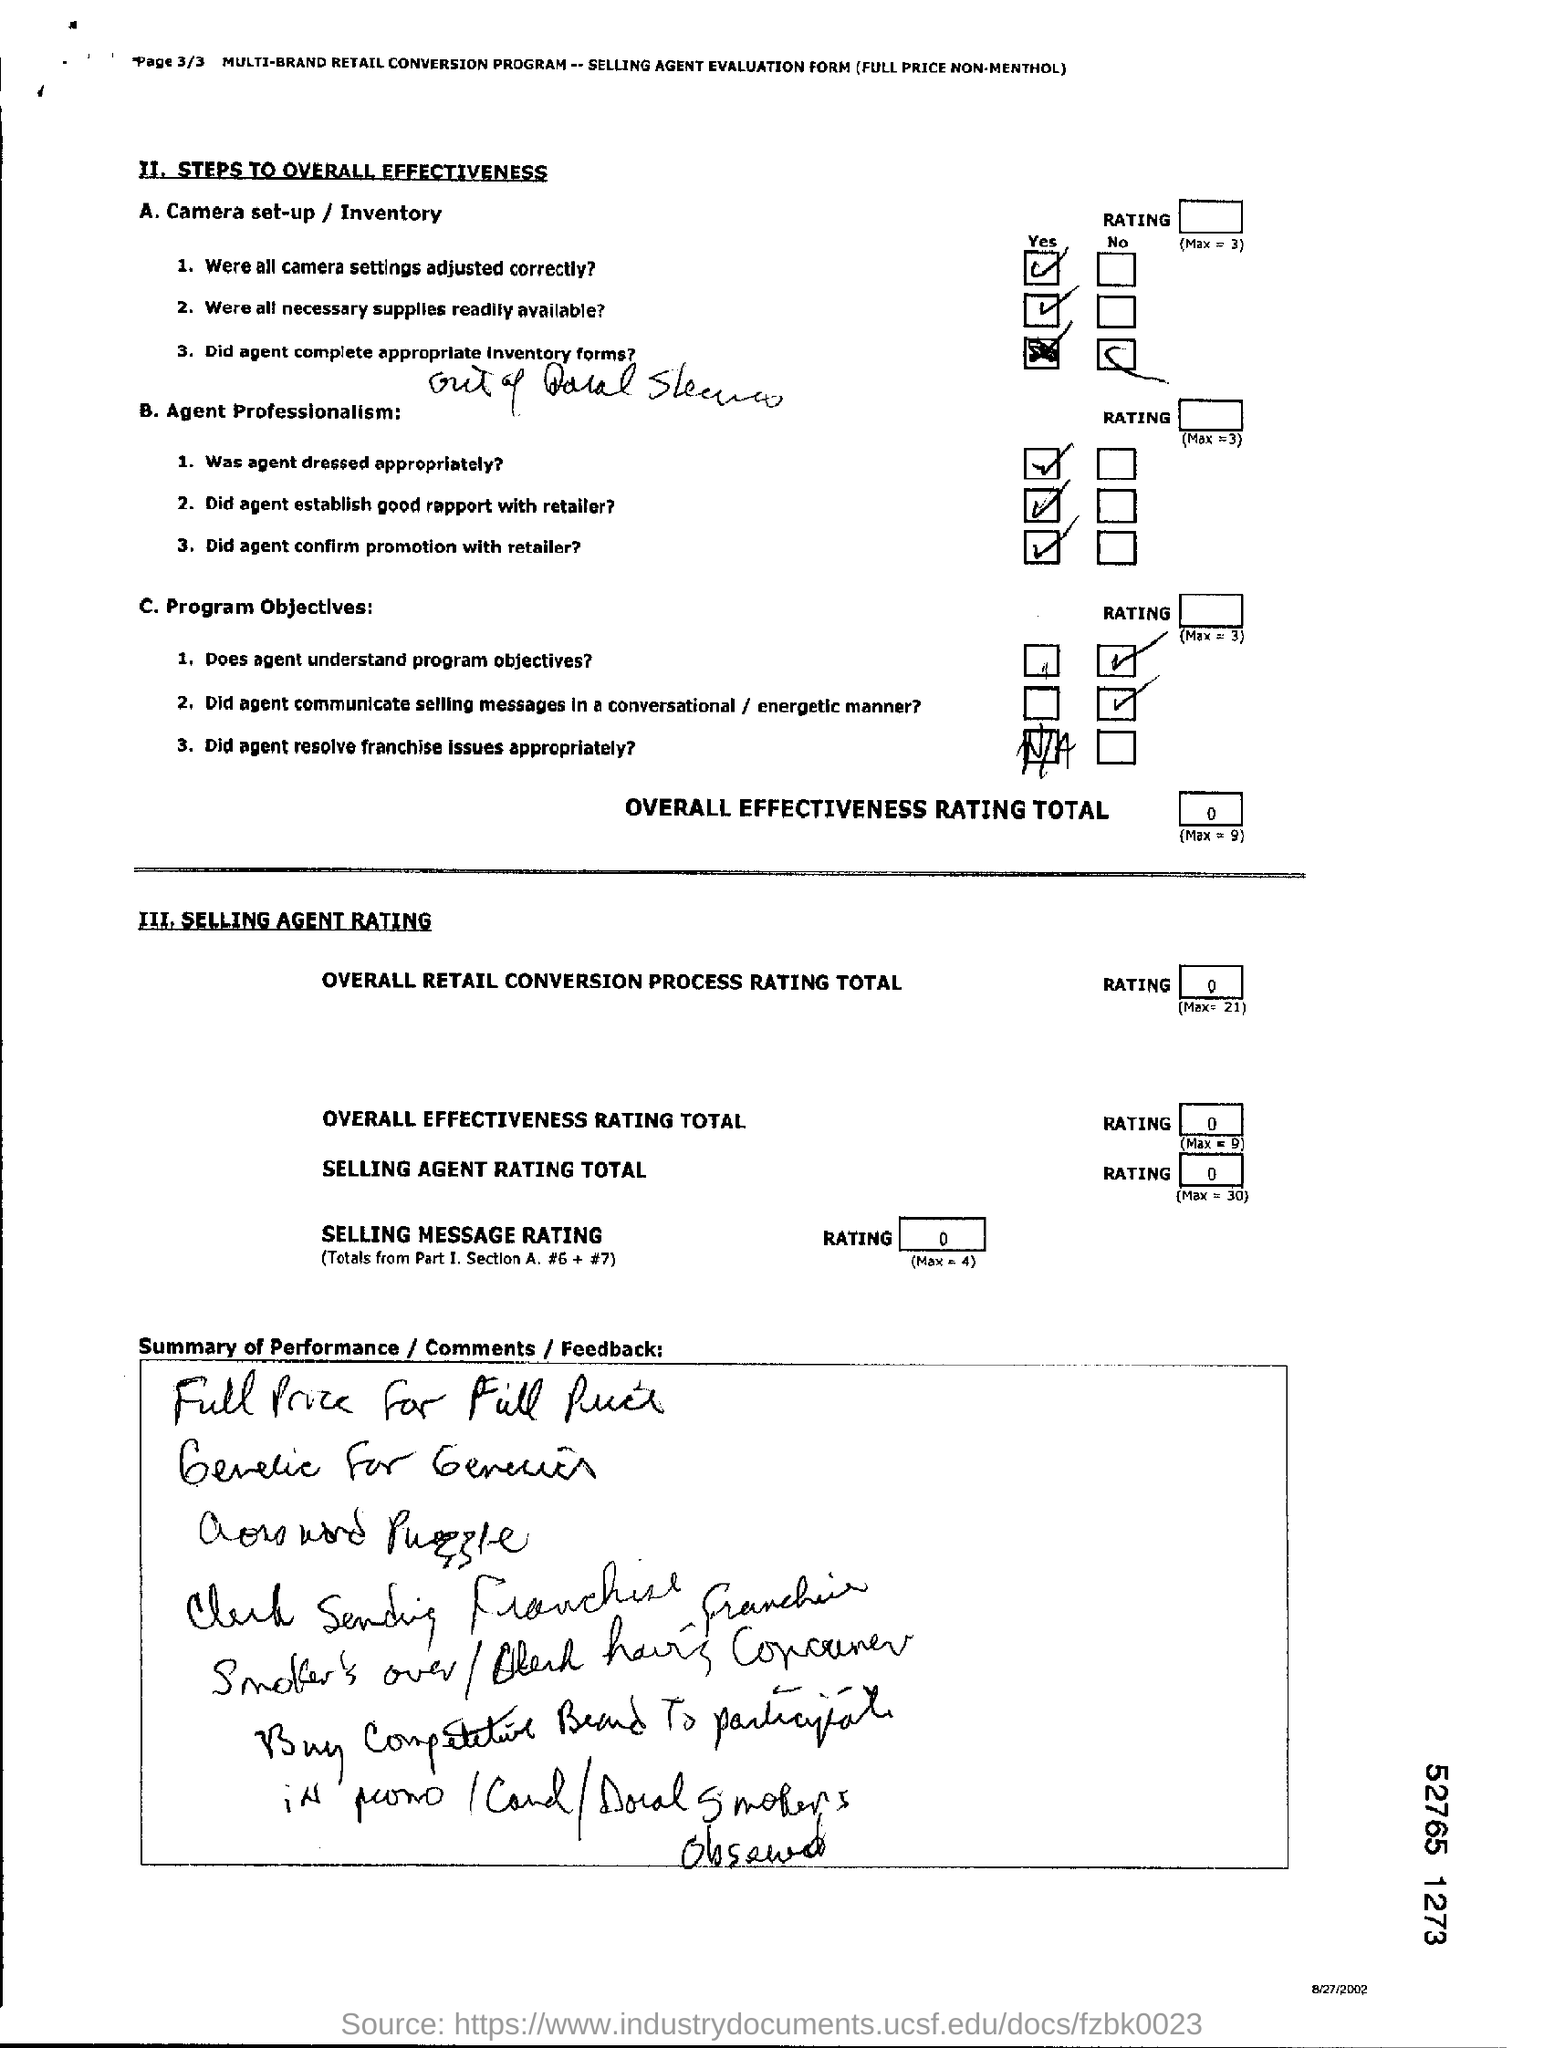Can you tell me what the main purpose of this document is? The document in the image appears to be a multi-brand retail conversion program evaluation form, specifically intended for assessing the effectiveness of a selling agent. It contains sections for rating camera setup, inventory, agent professionalism, program objectives, and overall selling agent effectiveness. The checklist format suggests its use as a tool for standardizing performance assessment during sales events or promotions. 